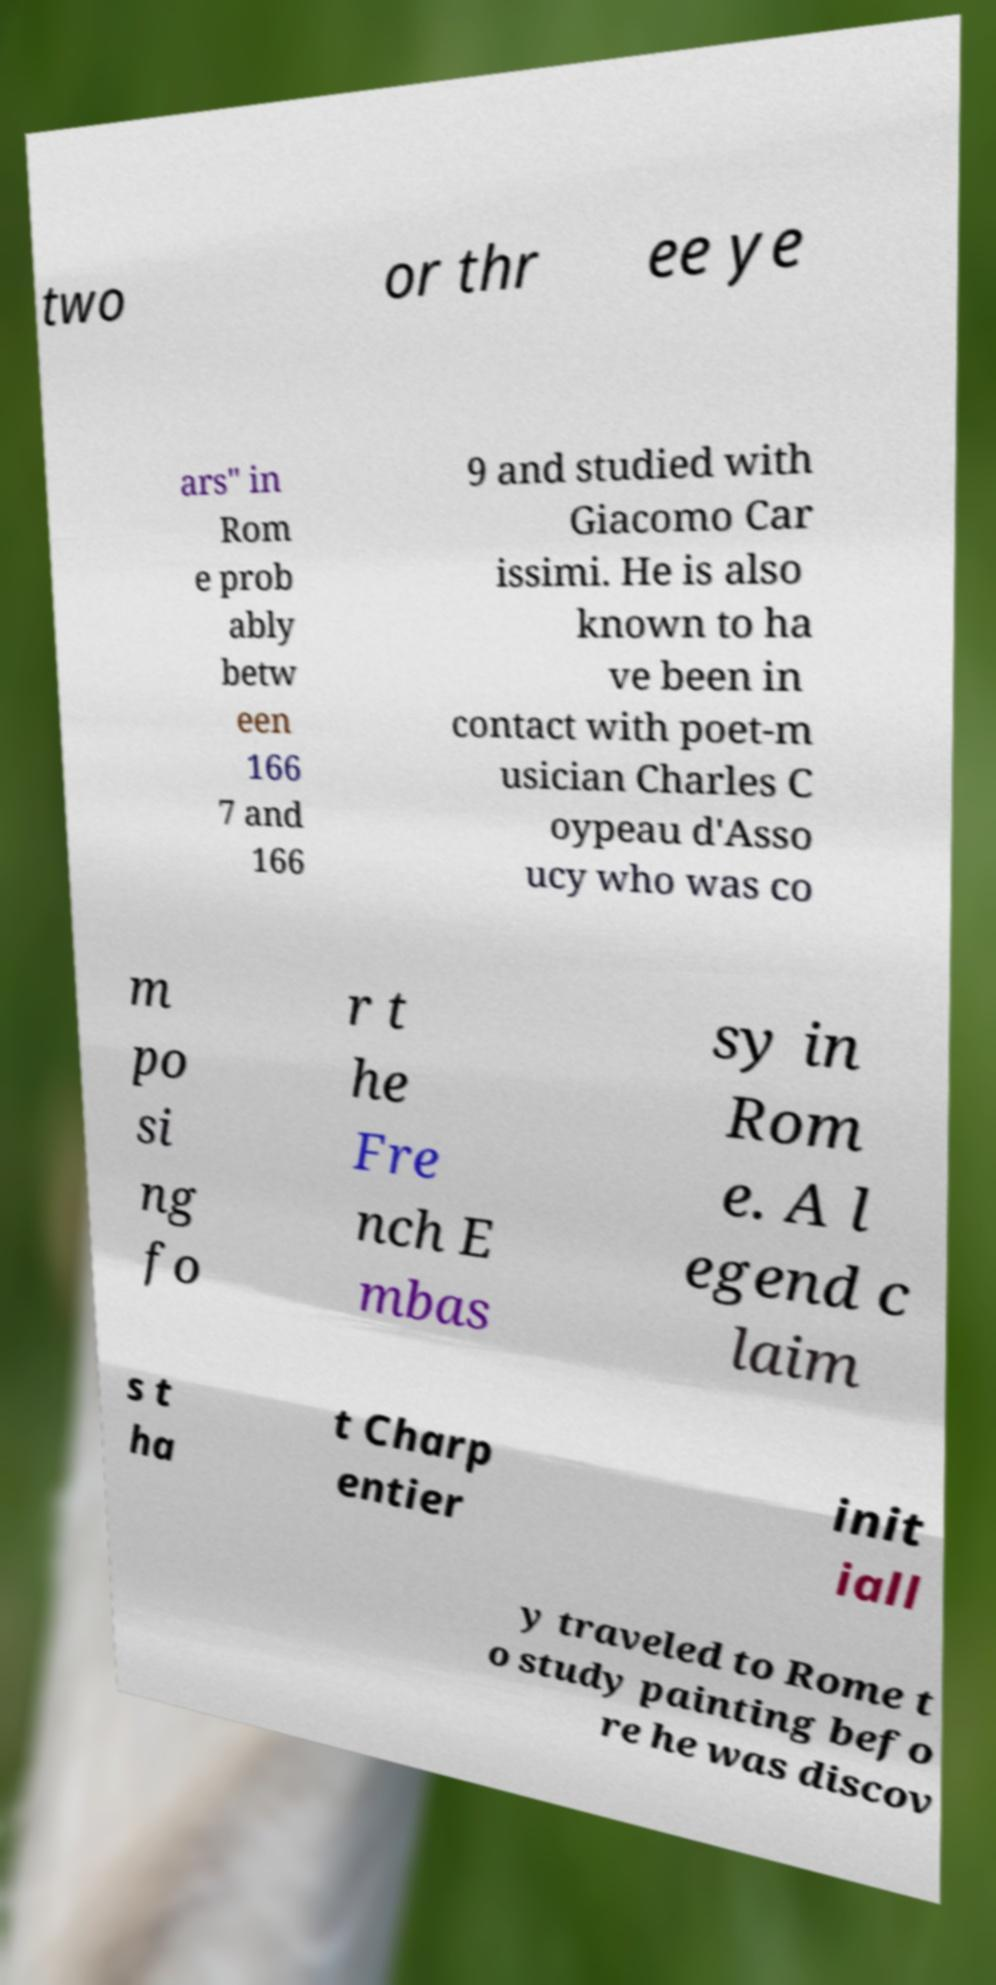There's text embedded in this image that I need extracted. Can you transcribe it verbatim? two or thr ee ye ars" in Rom e prob ably betw een 166 7 and 166 9 and studied with Giacomo Car issimi. He is also known to ha ve been in contact with poet-m usician Charles C oypeau d'Asso ucy who was co m po si ng fo r t he Fre nch E mbas sy in Rom e. A l egend c laim s t ha t Charp entier init iall y traveled to Rome t o study painting befo re he was discov 